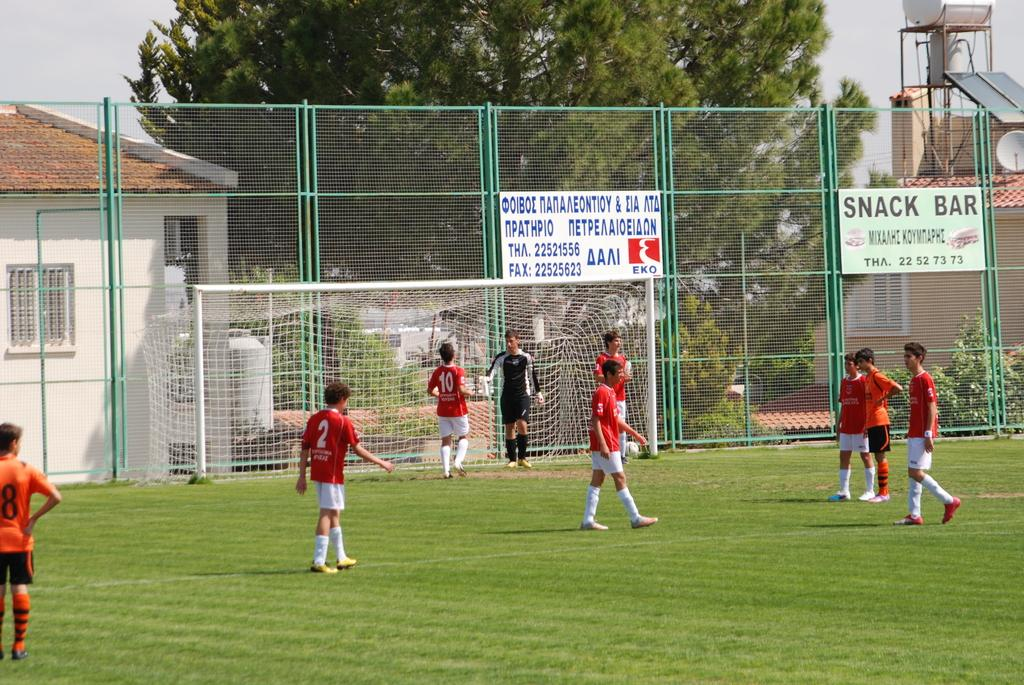<image>
Share a concise interpretation of the image provided. A soccer game is going on under a sign that says Snack bar. 